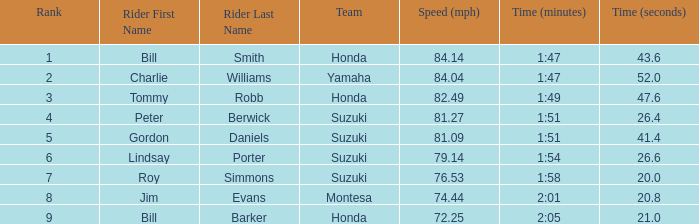What was the time for Peter Berwick of Team Suzuki? 1:51.26.4. 